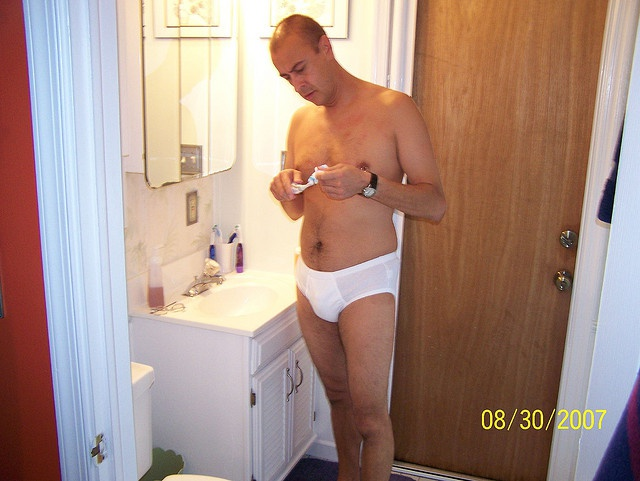Describe the objects in this image and their specific colors. I can see people in maroon, brown, lightgray, and salmon tones, sink in maroon, beige, tan, and darkgray tones, toilet in maroon, darkgray, beige, tan, and darkgreen tones, bottle in maroon, tan, brown, and lightgray tones, and toothbrush in maroon, lightgray, tan, and darkgray tones in this image. 